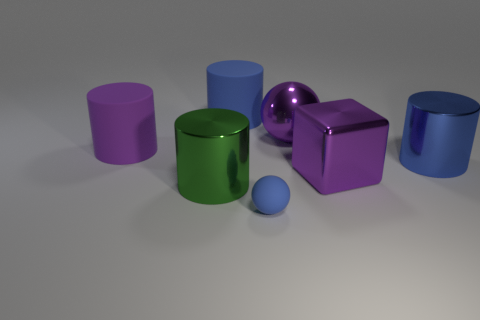Subtract all purple cylinders. How many cylinders are left? 3 Subtract all purple balls. How many blue cylinders are left? 2 Subtract all purple cylinders. How many cylinders are left? 3 Subtract 2 cylinders. How many cylinders are left? 2 Add 2 large blue metal objects. How many objects exist? 9 Subtract all brown cylinders. Subtract all purple blocks. How many cylinders are left? 4 Subtract all blocks. How many objects are left? 6 Add 6 purple matte objects. How many purple matte objects are left? 7 Add 6 tiny cyan metal balls. How many tiny cyan metal balls exist? 6 Subtract 0 gray spheres. How many objects are left? 7 